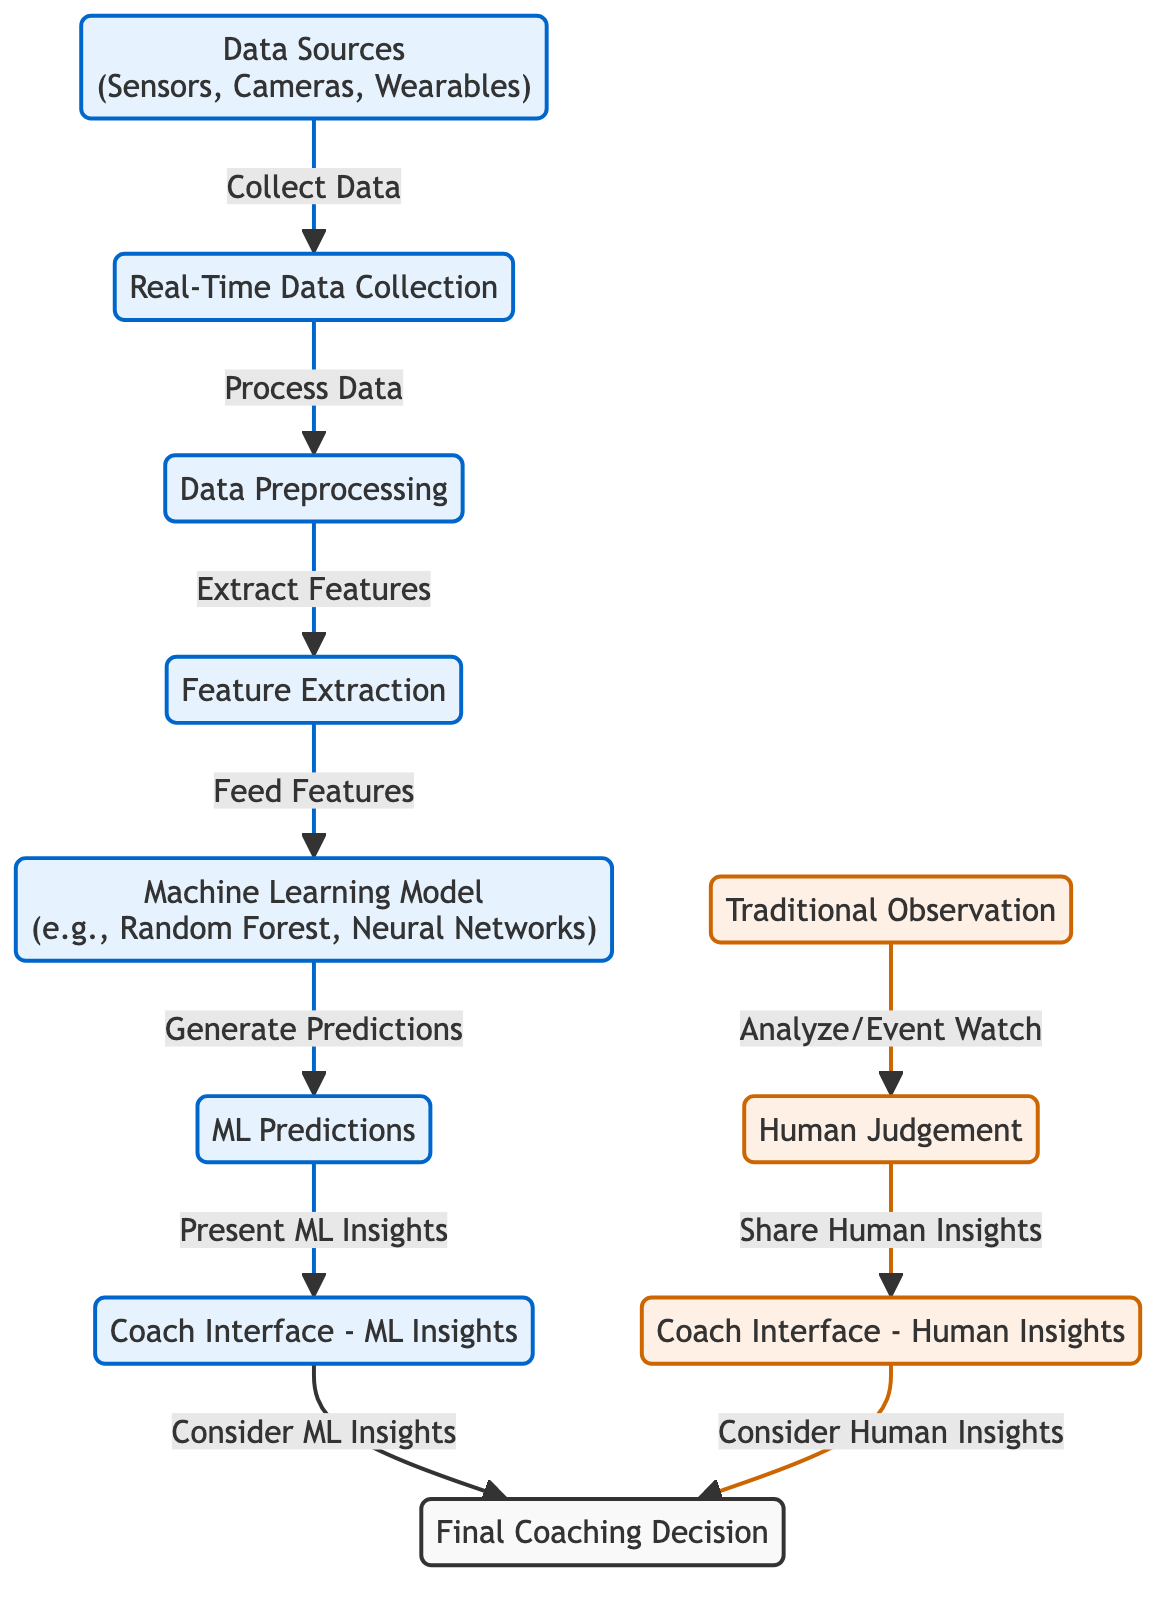What is the starting point of the ML path in the diagram? The starting point for the ML path is "Data Sources," which collects data from various inputs like sensors, cameras, and wearables.
Answer: Data Sources How many paths are depicted in the diagram? There are two distinct paths shown in the diagram: one for the machine learning process and one for human observation and judgment.
Answer: Two What do ML predictions connect to in the flowchart? The ML predictions connect to "Coach Interface - ML Insights," where the insights generated by the machine learning model are presented.
Answer: Coach Interface - ML Insights Which node comes after "Feature Extraction" in the machine learning path? The node that comes next after "Feature Extraction" is "Machine Learning Model," where extracted features are fed into the model to generate predictions.
Answer: Machine Learning Model Which interface considers human insights in the coaching decision process? The interface that considers human insights is "Coach Interface - Human Insights," which allows for human judgment to be shared and analyzed.
Answer: Coach Interface - Human Insights What is the final node in the decision-making process of the flowchart? The final node in the decision-making process is "Final Coaching Decision," where insights from both the machine learning and human paths are combined.
Answer: Final Coaching Decision How does "Real-Time Data Collection" relate to "Data Preprocessing"? "Real-Time Data Collection" feeds into "Data Preprocessing," which involves processing the data collected in real-time to prepare it for analysis.
Answer: Process Data What type of algorithm is mentioned as an example in the "Machine Learning Model" node? The example algorithm mentioned in the "Machine Learning Model" node is "Random Forest," along with "Neural Networks."
Answer: Random Forest, Neural Networks Which path involves analyzing events through watch and observation? The path that involves analyzing events through watch and observation is the traditional human observation path, which leads to "Human Judgment."
Answer: Traditional Observation 